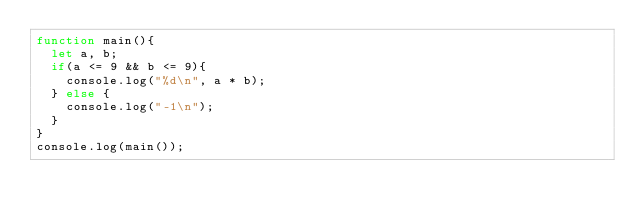<code> <loc_0><loc_0><loc_500><loc_500><_JavaScript_>function main(){
	let a, b;
	if(a <= 9 && b <= 9){
		console.log("%d\n", a * b);
	} else {
		console.log("-1\n");
	}
}
console.log(main());</code> 